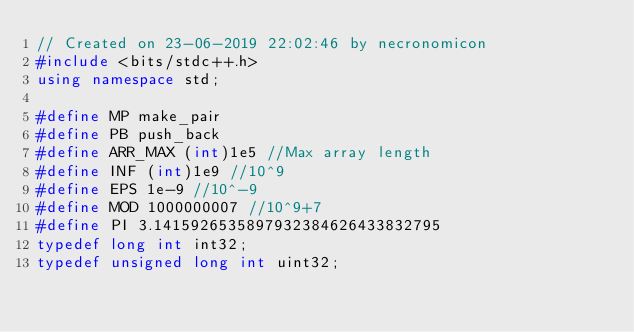Convert code to text. <code><loc_0><loc_0><loc_500><loc_500><_C++_>// Created on 23-06-2019 22:02:46 by necronomicon
#include <bits/stdc++.h>
using namespace std;

#define MP make_pair
#define PB push_back
#define ARR_MAX (int)1e5 //Max array length
#define INF (int)1e9 //10^9
#define EPS 1e-9 //10^-9
#define MOD 1000000007 //10^9+7
#define PI 3.1415926535897932384626433832795
typedef long int int32;
typedef unsigned long int uint32;</code> 